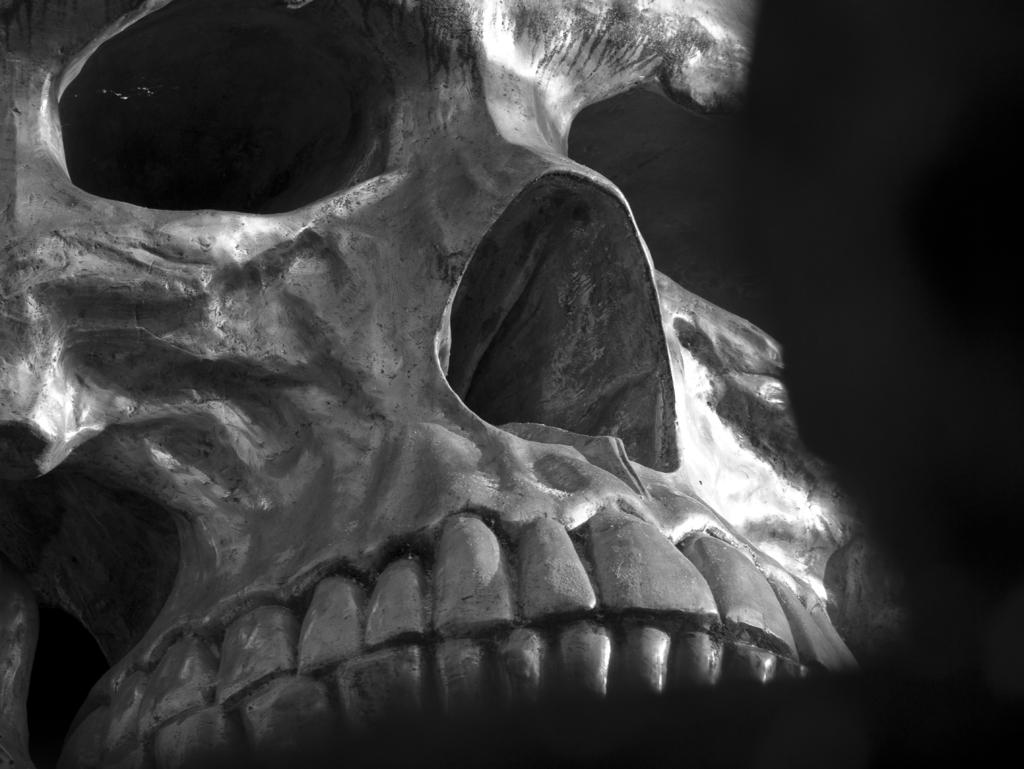What is the main subject of the image? The main subject of the image is a skull. What can be observed about the background of the image? The background of the image is dark. What type of party is happening in the image? There is no party depicted in the image; it features a skull with a dark background. In which direction is the test being taken in the image? There is no test present in the image; it only features a skull and a dark background. 